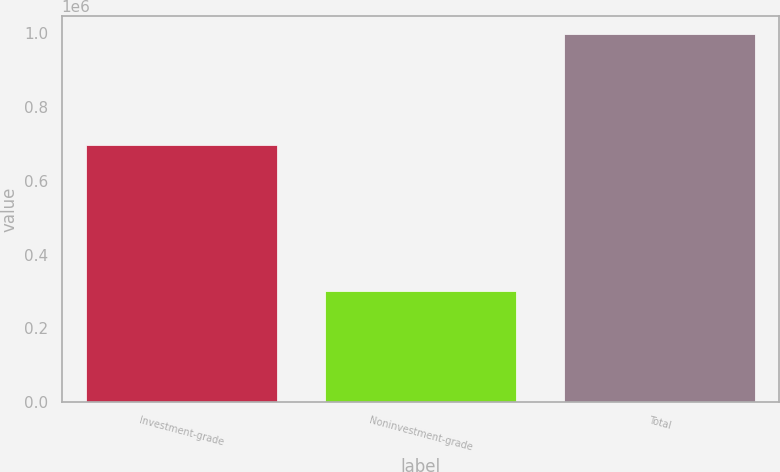Convert chart to OTSL. <chart><loc_0><loc_0><loc_500><loc_500><bar_chart><fcel>Investment-grade<fcel>Noninvestment-grade<fcel>Total<nl><fcel>696555<fcel>301318<fcel>997873<nl></chart> 